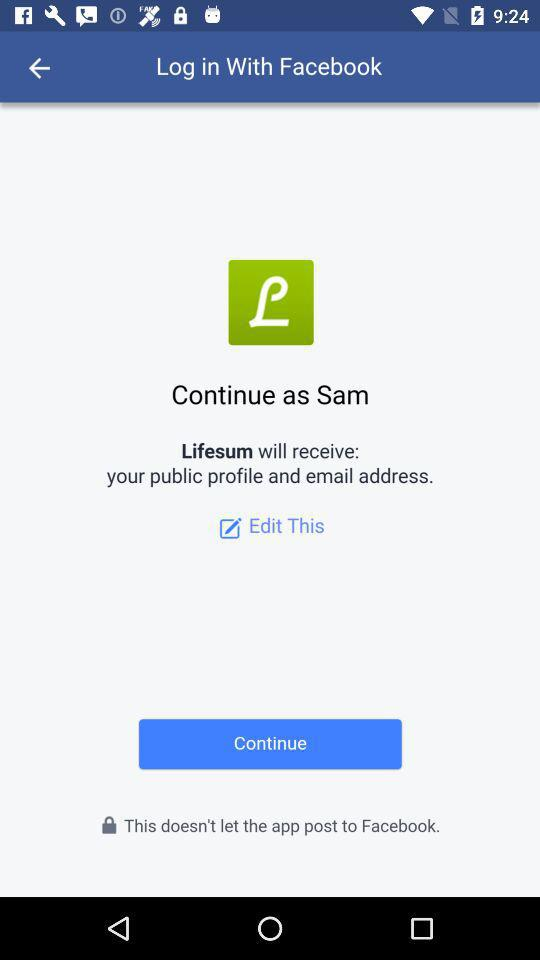What application will receive a public profile and email address? The application that will receive your public profile and email address is "Lifesum". 